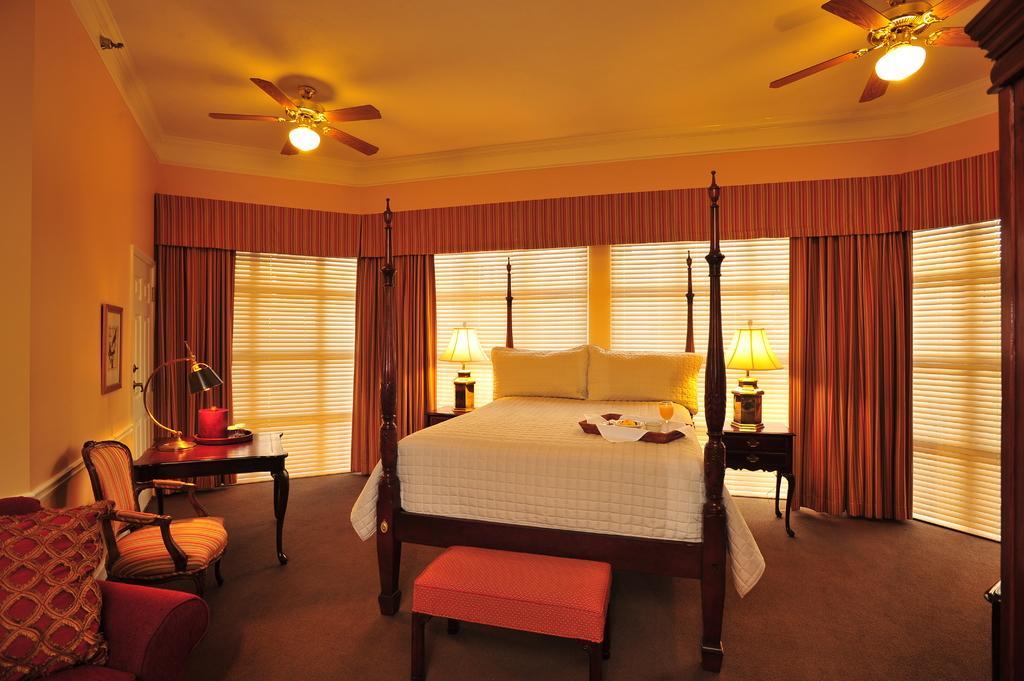How would you summarize this image in a sentence or two? In this picture we can see there is a bed, chair, couch and tables and on the bed there is a tray and on the train there are some food items and a glass. On the tables there are lamps and other things and on the couch there is a cushion. On the left side of the bed there is a wall with a photo frame. Behind the bed there are windows with curtains and at the top there are ceiling fans with lights. 